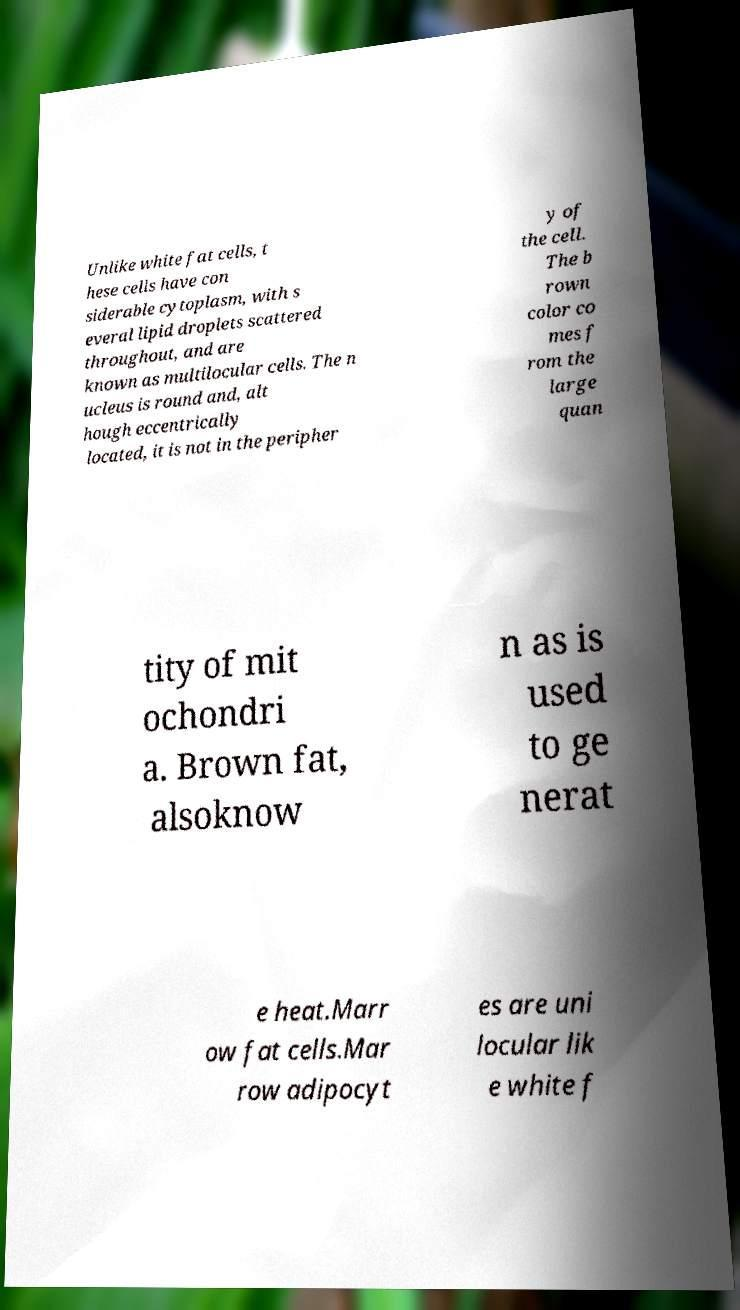Please identify and transcribe the text found in this image. Unlike white fat cells, t hese cells have con siderable cytoplasm, with s everal lipid droplets scattered throughout, and are known as multilocular cells. The n ucleus is round and, alt hough eccentrically located, it is not in the peripher y of the cell. The b rown color co mes f rom the large quan tity of mit ochondri a. Brown fat, alsoknow n as is used to ge nerat e heat.Marr ow fat cells.Mar row adipocyt es are uni locular lik e white f 